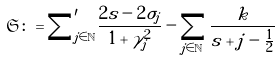<formula> <loc_0><loc_0><loc_500><loc_500>\mathfrak S \colon = { \sum } ^ { \prime } _ { j \in \mathbb { N } } \frac { 2 s - 2 \sigma _ { j } } { 1 + \gamma _ { j } ^ { 2 } } - \sum _ { j \in \mathbb { N } } \frac { k } { s + j - \frac { 1 } { 2 } }</formula> 